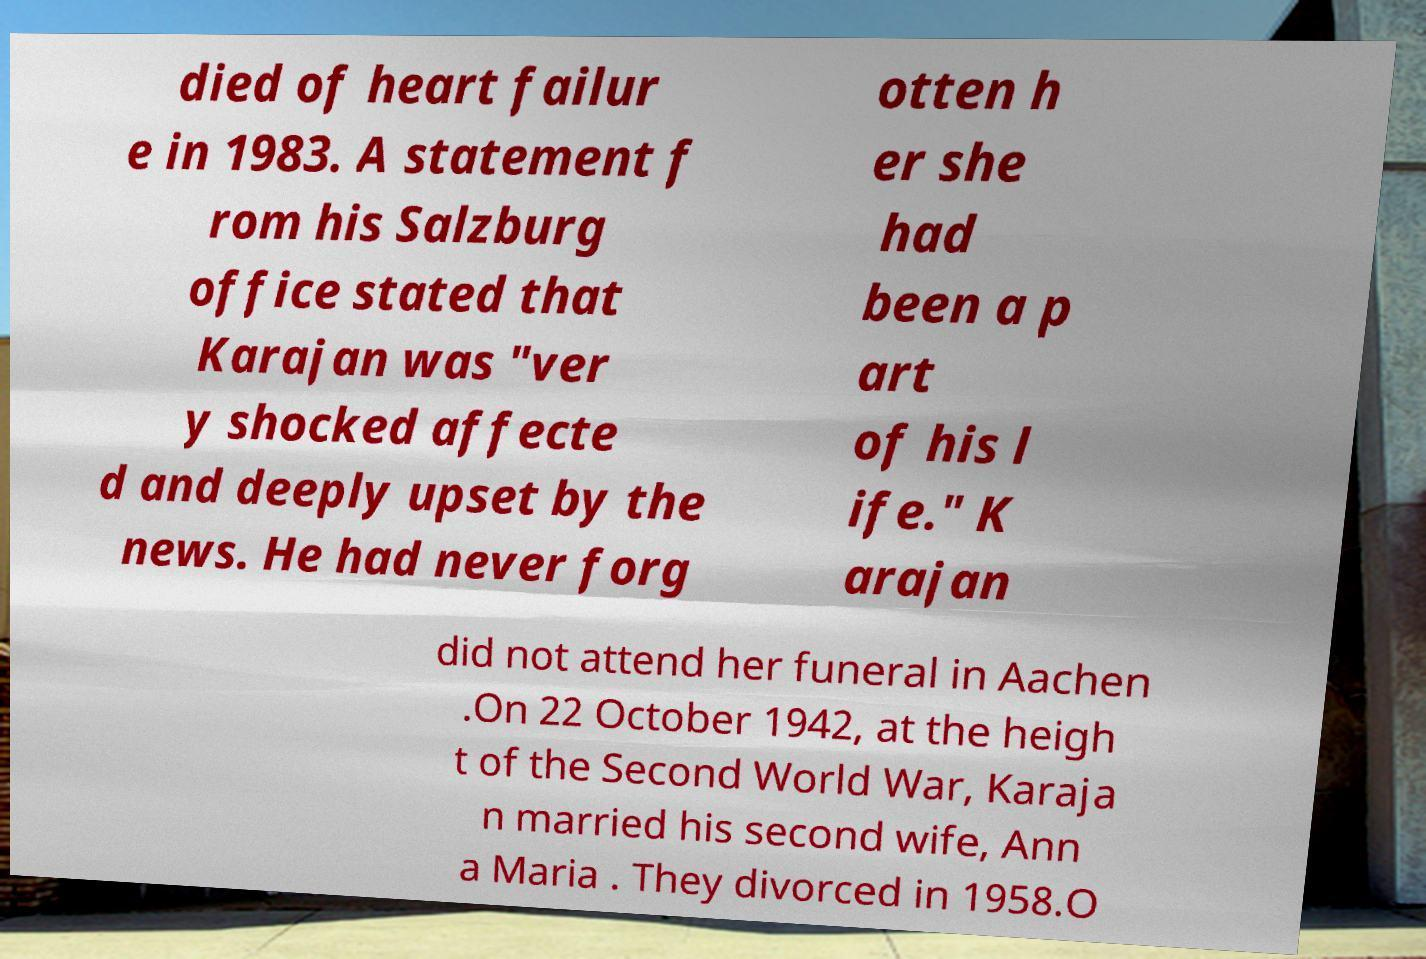Can you read and provide the text displayed in the image?This photo seems to have some interesting text. Can you extract and type it out for me? died of heart failur e in 1983. A statement f rom his Salzburg office stated that Karajan was "ver y shocked affecte d and deeply upset by the news. He had never forg otten h er she had been a p art of his l ife." K arajan did not attend her funeral in Aachen .On 22 October 1942, at the heigh t of the Second World War, Karaja n married his second wife, Ann a Maria . They divorced in 1958.O 